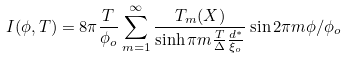Convert formula to latex. <formula><loc_0><loc_0><loc_500><loc_500>I ( \phi , T ) = 8 \pi \frac { T } { \phi _ { o } } \sum _ { m = 1 } ^ { \infty } \frac { T _ { m } ( X ) } { \sinh \pi m \frac { T } { \Delta } \frac { d ^ { * } } { \xi _ { o } } } \sin 2 \pi m \phi / \phi _ { o }</formula> 